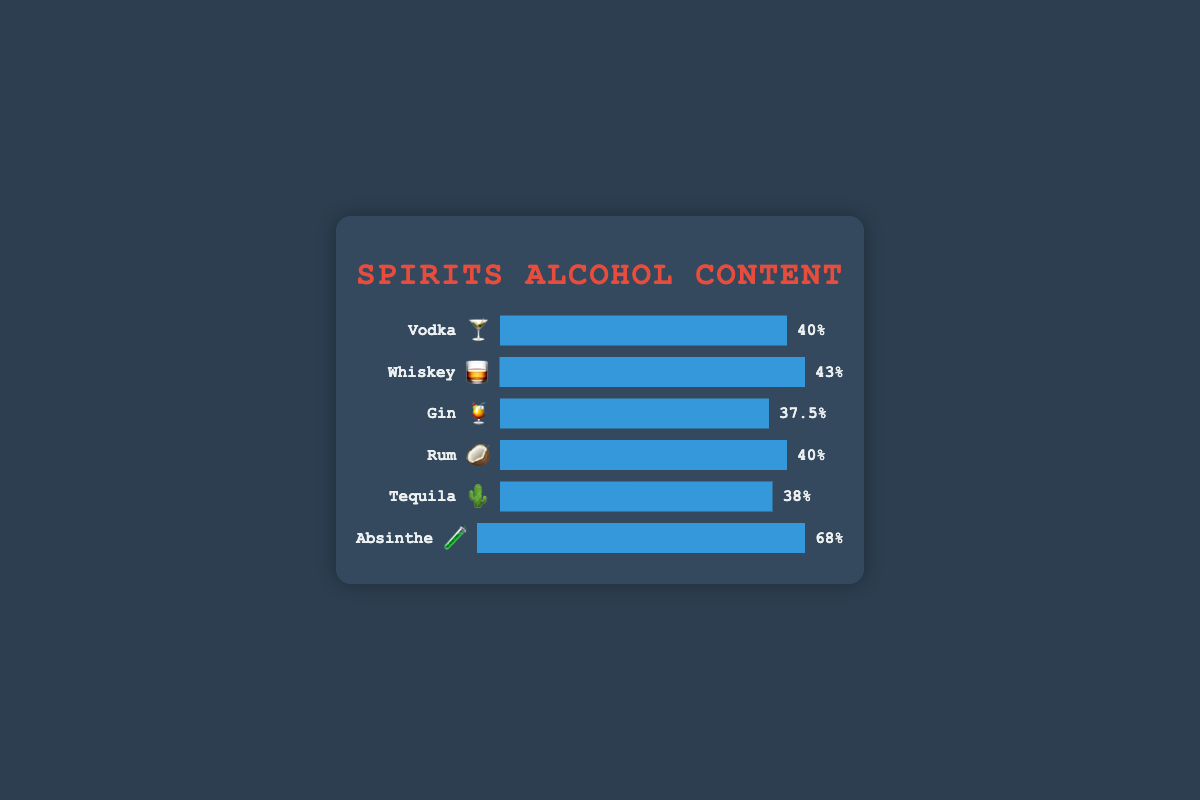What spirit has the highest alcohol content? The highest value for alcohol content percentage in the chart is 68%, which corresponds to Absinthe.
Answer: Absinthe Which spirit has the lowest alcohol content? By observing the values, Gin has the lowest alcohol percentage, which is 37.5%.
Answer: Gin What is the average alcohol content percentage of all the spirits listed? Sum of all alcohol percentages: 40 (Vodka) + 43 (Whiskey) + 37.5 (Gin) + 40 (Rum) + 38 (Tequila) + 68 (Absinthe) = 266.5. Dividing by the number of spirits (6), the average is 266.5/6 ≈ 44.42.
Answer: 44.42 How much higher is the alcohol content of Absinthe compared to Tequila? Absinthe has an alcohol content of 68%, while Tequila has 38%. The difference is 68 - 38 = 30%.
Answer: 30% Which spirits have the same alcohol percentage? By comparing the alcohol percentages, both Vodka and Rum have an alcohol content of 40%.
Answer: Vodka and Rum Rank the spirits from highest to lowest based on their alcohol content percentage. By ordering the spirits from highest to lowest alcohol content: Absinthe (68%), Whiskey (43%), Vodka (40%), Rum (40%), Tequila (38%), Gin (37.5%).
Answer: Absinthe, Whiskey, Vodka, Rum, Tequila, Gin If you combine Vodka and Whiskey, what is their total alcohol content percentage? The alcohol content of Vodka is 40% and Whiskey is 43%. Their total is 40 + 43 = 83%.
Answer: 83% Which spirit's alcohol content is closer to the average alcohol content of all spirits listed? The average alcohol content is 44.42%. Whiskey at 43% is the closest to this average.
Answer: Whiskey How does the alcohol content of Tequila compare to the combined average of Gin and Rum? The average of Gin (37.5%) and Rum (40%) is (37.5 + 40)/2 = 38.75%. Tequila’s alcohol content is 38%, which is slightly lower than 38.75%.
Answer: Lower How many spirits have an alcohol content above 40%? The spirits with more than 40% alcohol content are Absinthe (68%) and Whiskey (43%).
Answer: 2 